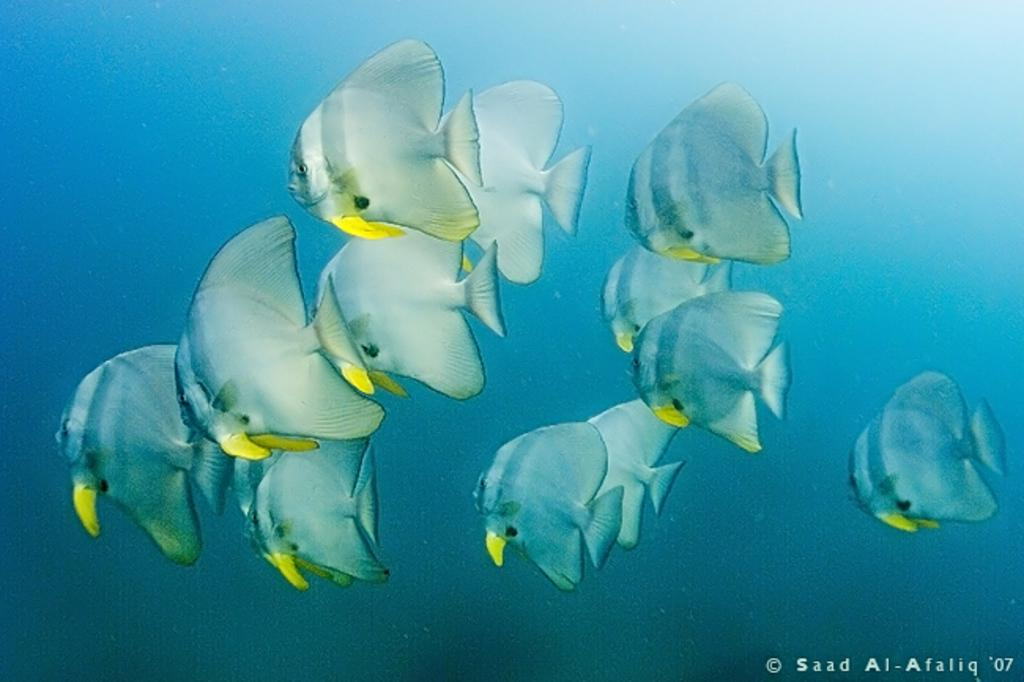What type of animals can be seen in the image? There are fishes in the image. What color are the fishes? The fishes are white in color. What are the fishes doing in the image? The fishes are swimming in the water. What color is the background of the image? The background of the image is blue. Is the image a photograph or a painting? The image might be a painting. Can you hear the fishes' voices in the image? Fishes do not have voices, so there is no sound to hear in the image. 